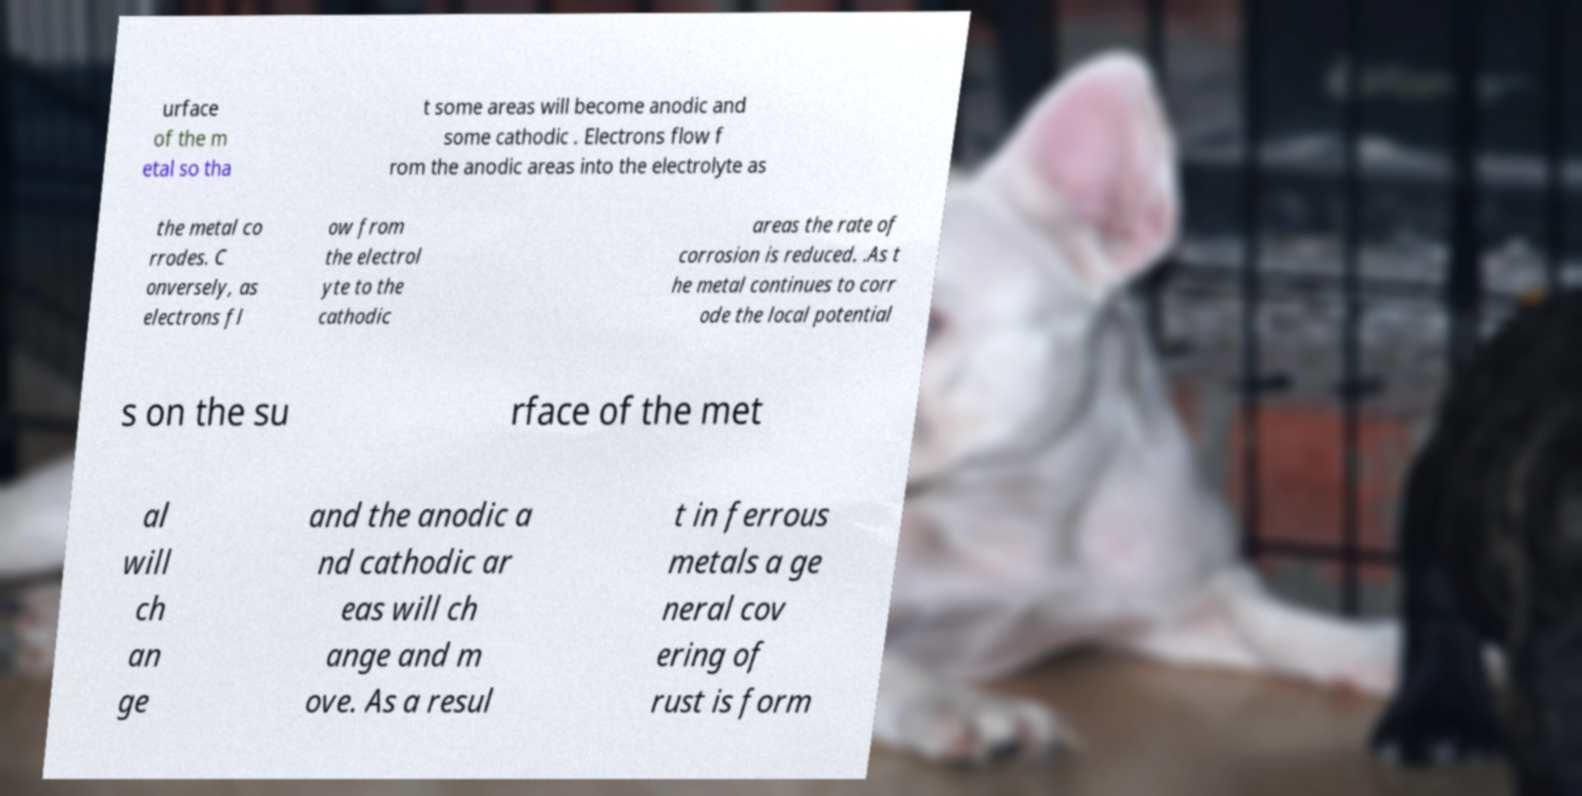For documentation purposes, I need the text within this image transcribed. Could you provide that? urface of the m etal so tha t some areas will become anodic and some cathodic . Electrons flow f rom the anodic areas into the electrolyte as the metal co rrodes. C onversely, as electrons fl ow from the electrol yte to the cathodic areas the rate of corrosion is reduced. .As t he metal continues to corr ode the local potential s on the su rface of the met al will ch an ge and the anodic a nd cathodic ar eas will ch ange and m ove. As a resul t in ferrous metals a ge neral cov ering of rust is form 